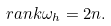Convert formula to latex. <formula><loc_0><loc_0><loc_500><loc_500>r a n k \omega _ { h } = 2 n .</formula> 